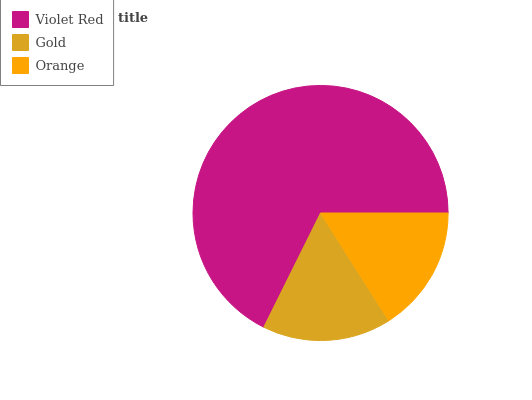Is Orange the minimum?
Answer yes or no. Yes. Is Violet Red the maximum?
Answer yes or no. Yes. Is Gold the minimum?
Answer yes or no. No. Is Gold the maximum?
Answer yes or no. No. Is Violet Red greater than Gold?
Answer yes or no. Yes. Is Gold less than Violet Red?
Answer yes or no. Yes. Is Gold greater than Violet Red?
Answer yes or no. No. Is Violet Red less than Gold?
Answer yes or no. No. Is Gold the high median?
Answer yes or no. Yes. Is Gold the low median?
Answer yes or no. Yes. Is Violet Red the high median?
Answer yes or no. No. Is Orange the low median?
Answer yes or no. No. 